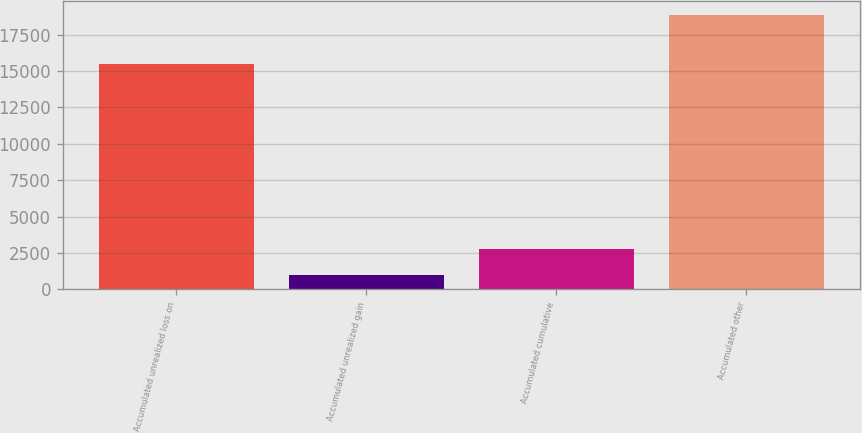Convert chart. <chart><loc_0><loc_0><loc_500><loc_500><bar_chart><fcel>Accumulated unrealized loss on<fcel>Accumulated unrealized gain<fcel>Accumulated cumulative<fcel>Accumulated other<nl><fcel>15474<fcel>1012<fcel>2796.6<fcel>18858<nl></chart> 